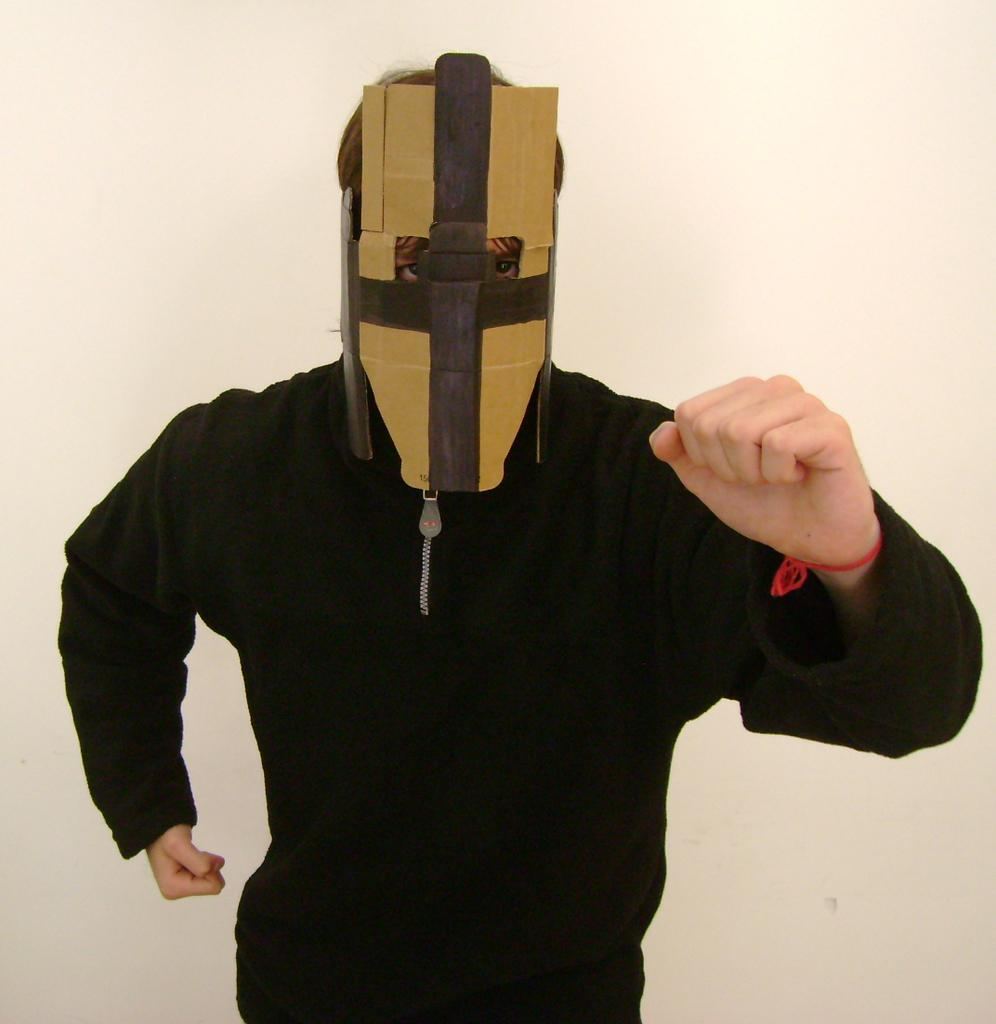Who or what is the main subject in the image? There is a person in the image. What is the person wearing on their upper body? The person is wearing a black color jacket. Is the person's face visible in the image? No, the person is wearing a mask. What is the color of the background in the image? The background of the image is white in color. Can you see any clams in the image? There are no clams present in the image. What type of toy is the person holding in the image? There is no toy visible in the image. 